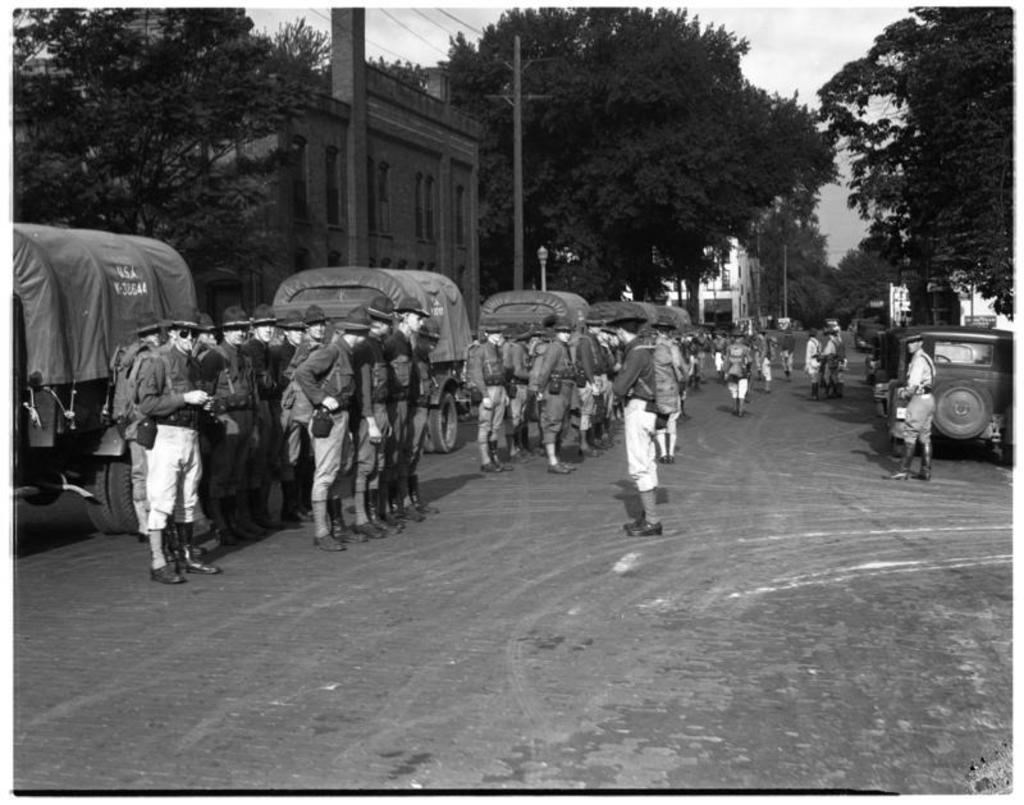Describe this image in one or two sentences. In this image I can see the group of people standing on the road. These people are wearing the uniforms and then hats. To the side of these people I can see many vehicles. In the background there are many trees, buildings and the sky. 